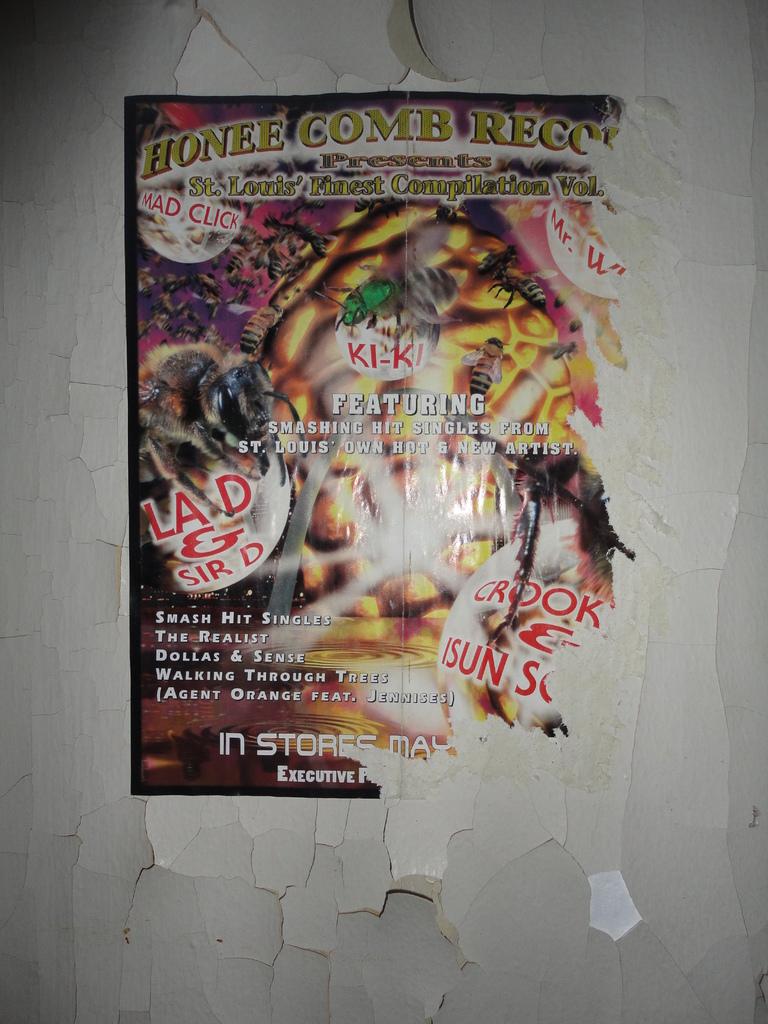What are some smash hit singles mentioned?
Your response must be concise. The realist, dollas & sense. 